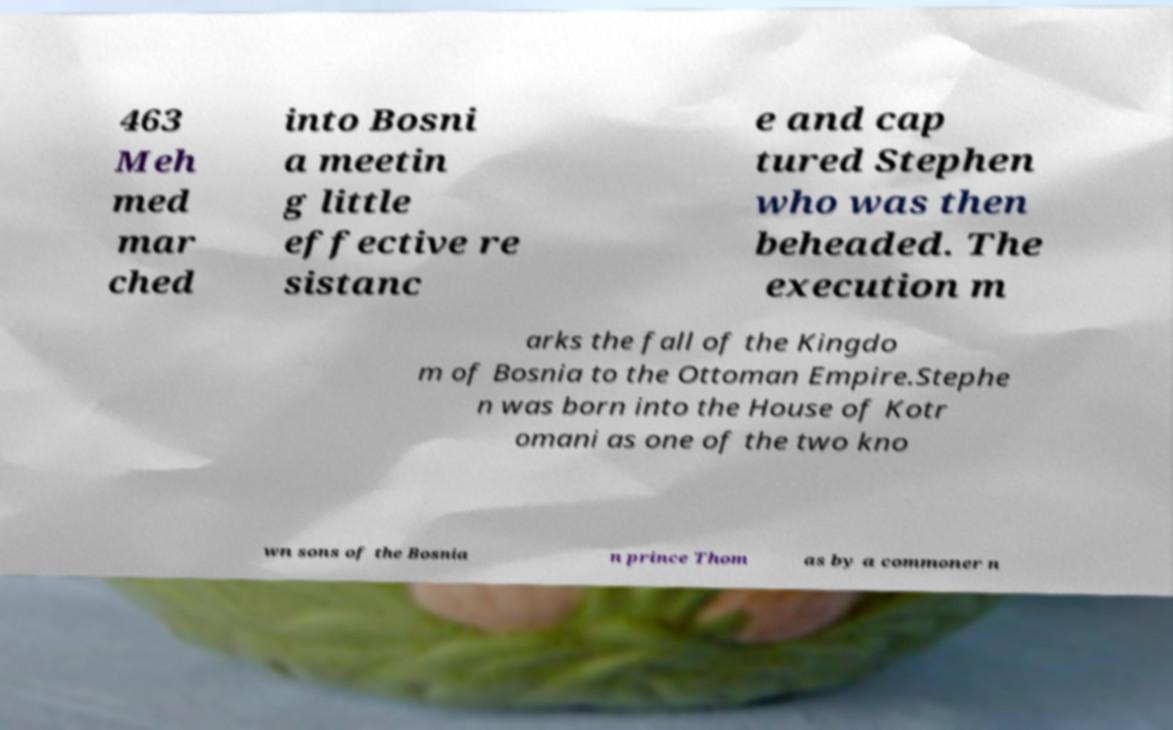What messages or text are displayed in this image? I need them in a readable, typed format. 463 Meh med mar ched into Bosni a meetin g little effective re sistanc e and cap tured Stephen who was then beheaded. The execution m arks the fall of the Kingdo m of Bosnia to the Ottoman Empire.Stephe n was born into the House of Kotr omani as one of the two kno wn sons of the Bosnia n prince Thom as by a commoner n 